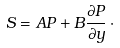Convert formula to latex. <formula><loc_0><loc_0><loc_500><loc_500>S = A P + B \frac { \partial { P } } { \partial { y } } \, \cdot</formula> 